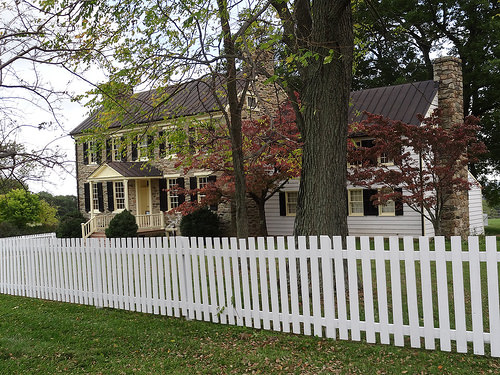<image>
Is there a fence in front of the tree? Yes. The fence is positioned in front of the tree, appearing closer to the camera viewpoint. 